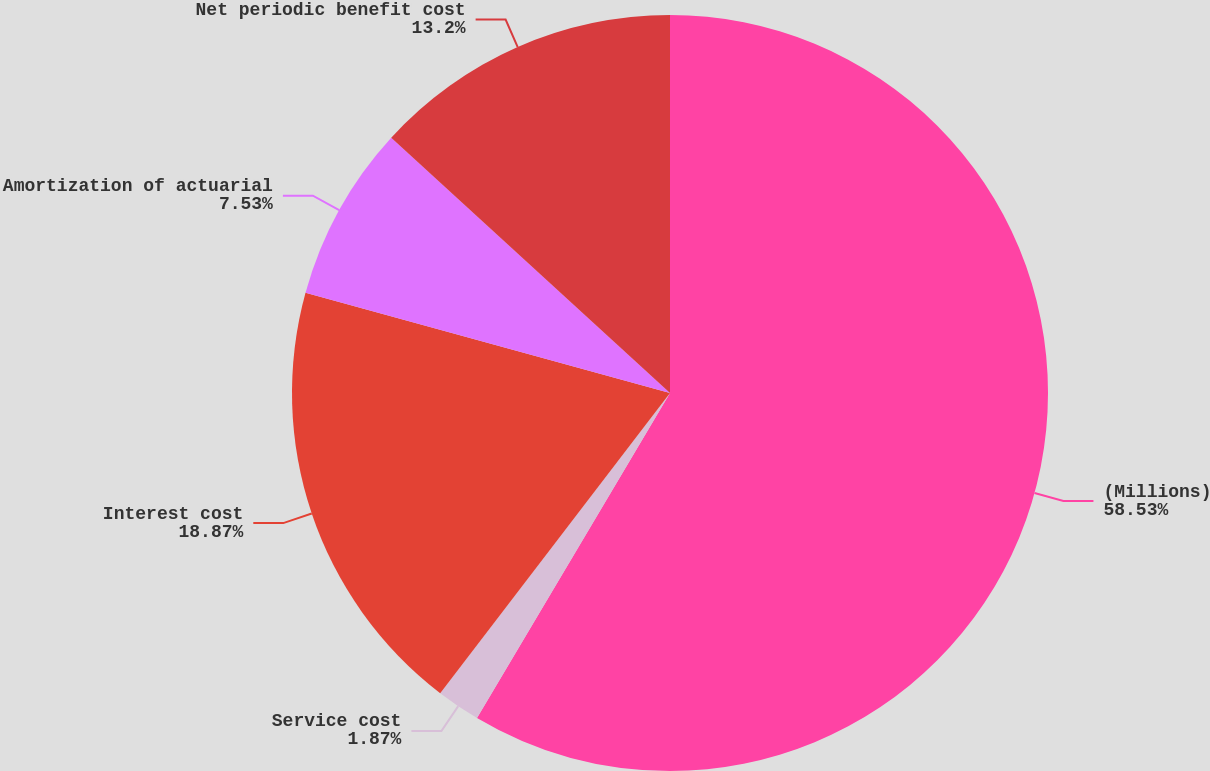Convert chart to OTSL. <chart><loc_0><loc_0><loc_500><loc_500><pie_chart><fcel>(Millions)<fcel>Service cost<fcel>Interest cost<fcel>Amortization of actuarial<fcel>Net periodic benefit cost<nl><fcel>58.53%<fcel>1.87%<fcel>18.87%<fcel>7.53%<fcel>13.2%<nl></chart> 